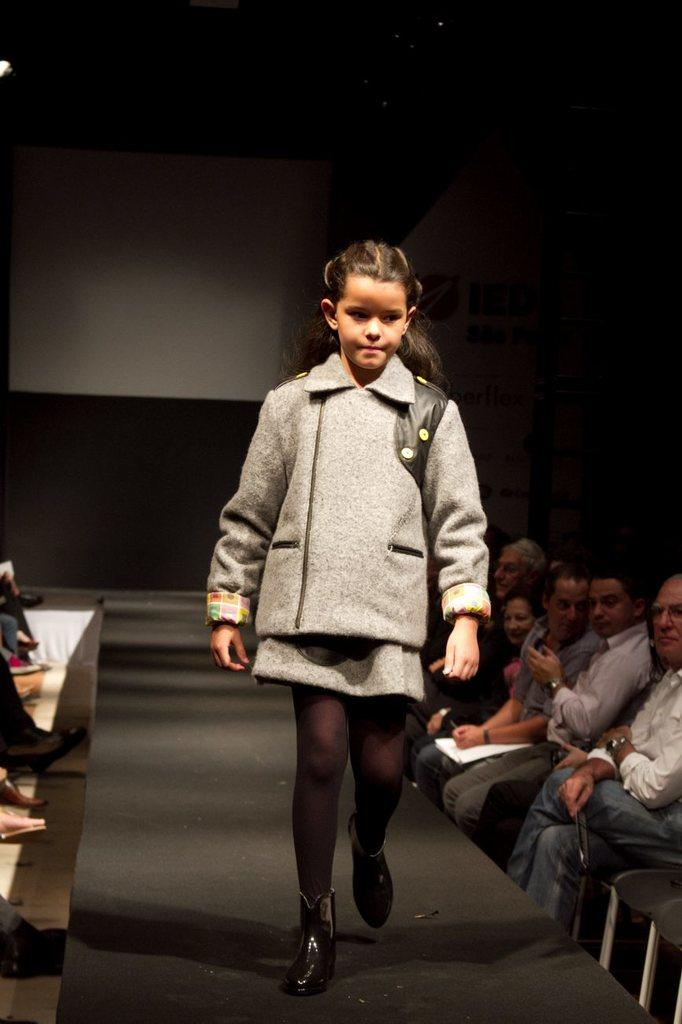Who is the main subject in the image? There is a girl in the image. What is the girl doing in the image? The girl is walking on a ramp in the image. Where is the girl walking in the image? The girl is walking on a ramp in the image. What else can be seen in the image besides the girl? People are sitting on chairs on both sides of the image. What type of bed is visible in the image? There is no bed present in the image. 